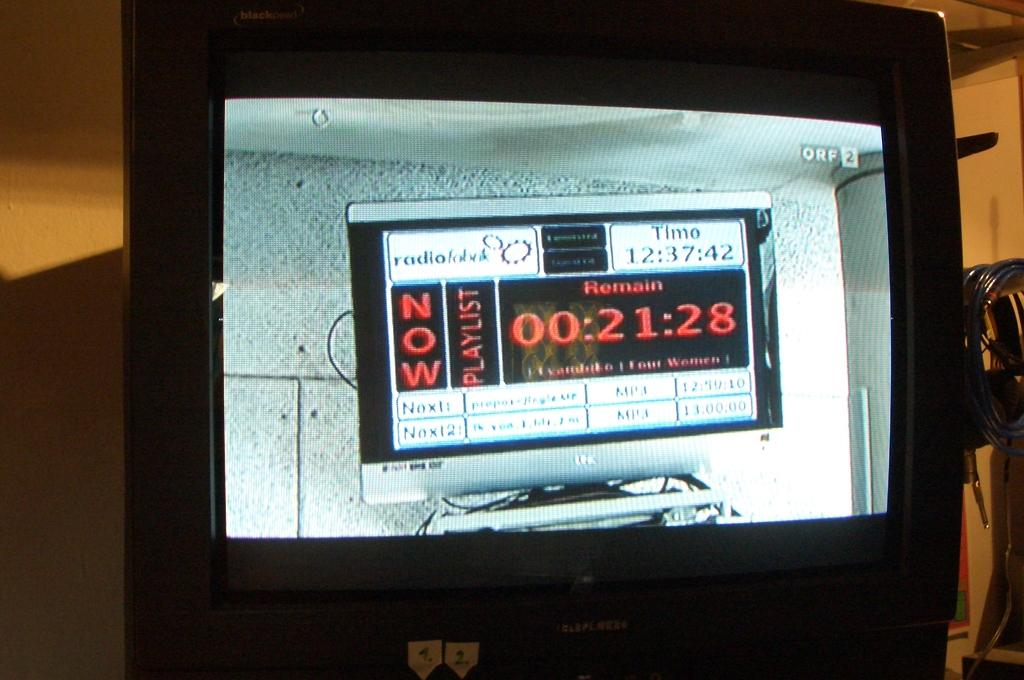<image>
Give a short and clear explanation of the subsequent image. A TV shows a picture of another monitor with the word "NOW" on it. 